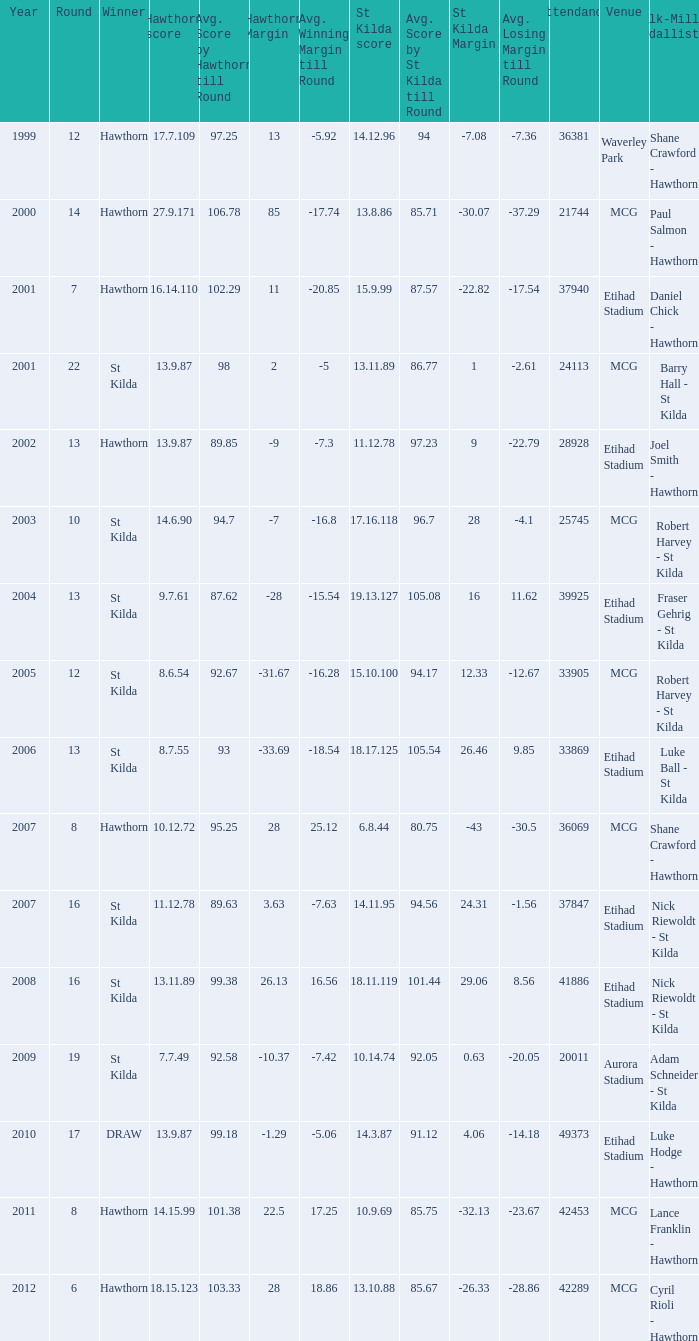What is the hawthorn score at the year 2000? 279171.0. 